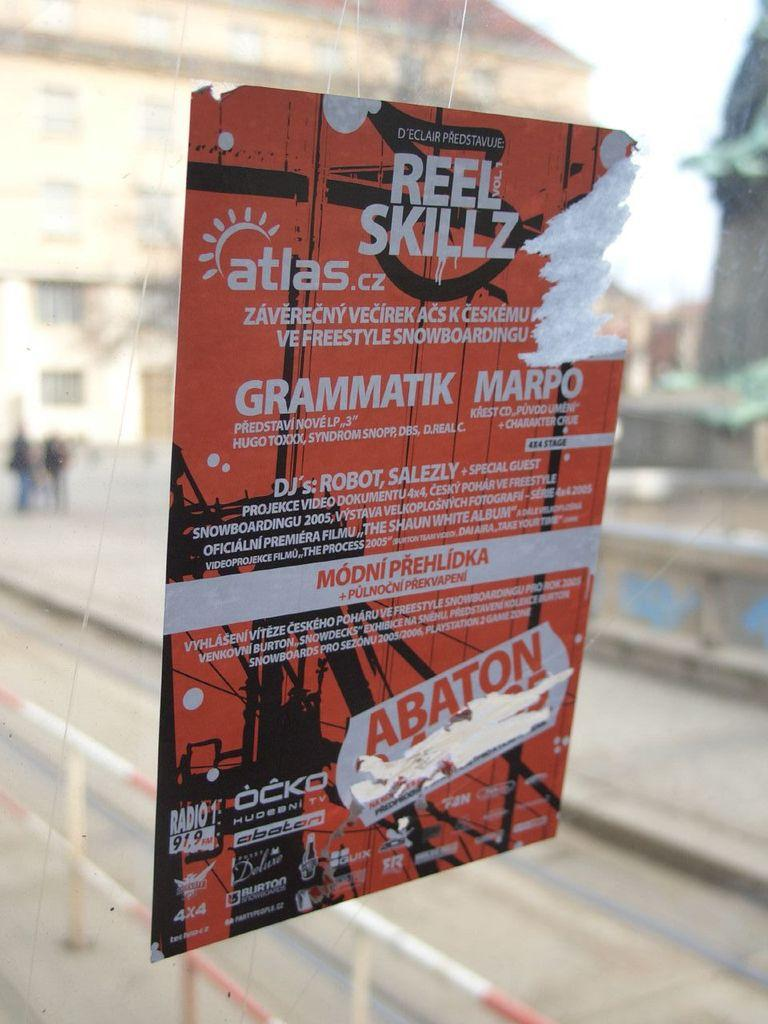<image>
Write a terse but informative summary of the picture. A sign on a window for Reel Skillz featuring various DJ's. 